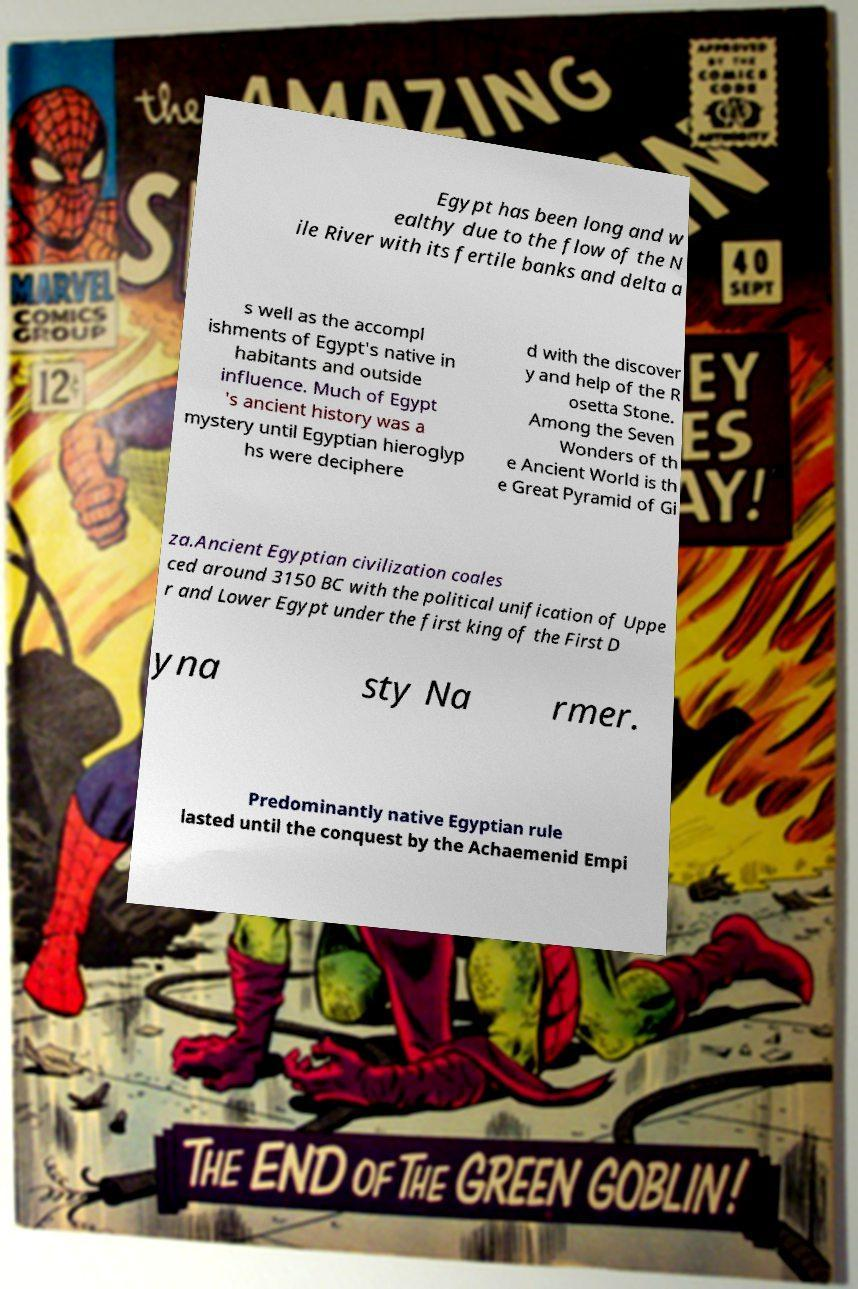What messages or text are displayed in this image? I need them in a readable, typed format. Egypt has been long and w ealthy due to the flow of the N ile River with its fertile banks and delta a s well as the accompl ishments of Egypt's native in habitants and outside influence. Much of Egypt 's ancient history was a mystery until Egyptian hieroglyp hs were deciphere d with the discover y and help of the R osetta Stone. Among the Seven Wonders of th e Ancient World is th e Great Pyramid of Gi za.Ancient Egyptian civilization coales ced around 3150 BC with the political unification of Uppe r and Lower Egypt under the first king of the First D yna sty Na rmer. Predominantly native Egyptian rule lasted until the conquest by the Achaemenid Empi 